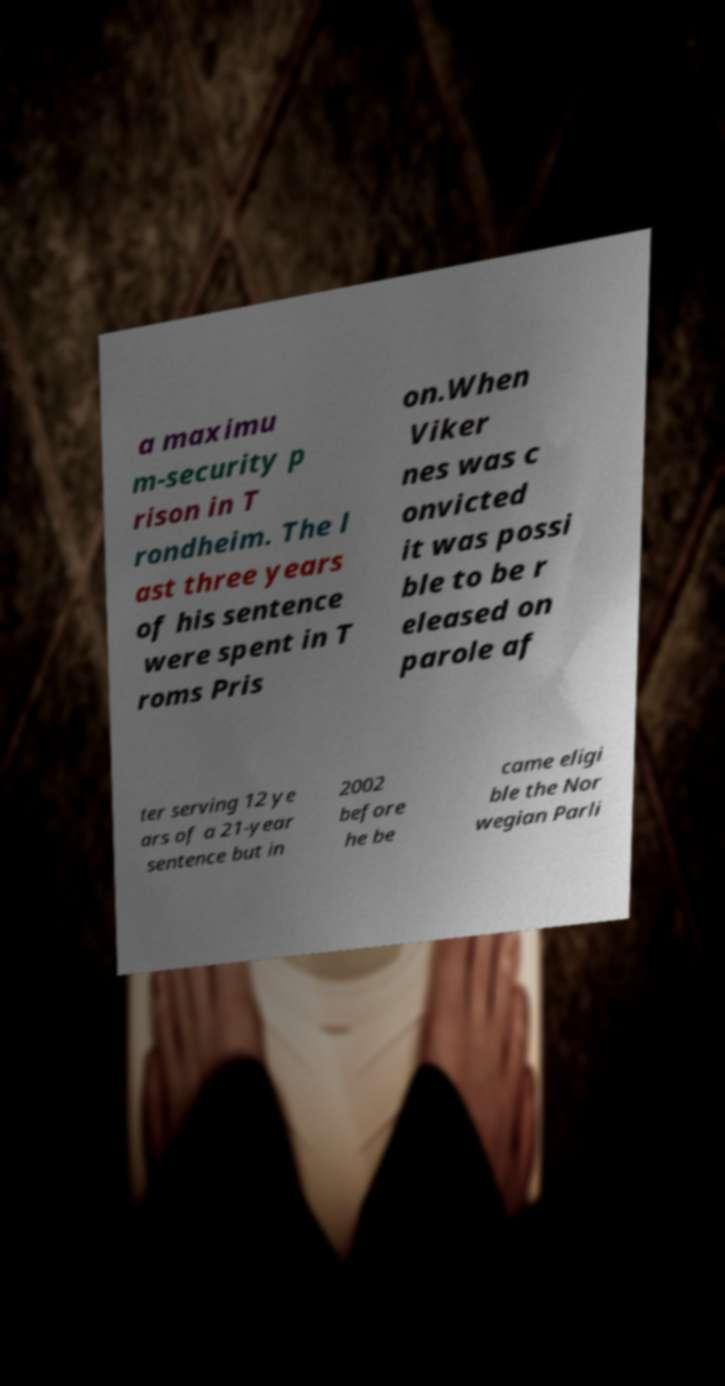I need the written content from this picture converted into text. Can you do that? a maximu m-security p rison in T rondheim. The l ast three years of his sentence were spent in T roms Pris on.When Viker nes was c onvicted it was possi ble to be r eleased on parole af ter serving 12 ye ars of a 21-year sentence but in 2002 before he be came eligi ble the Nor wegian Parli 